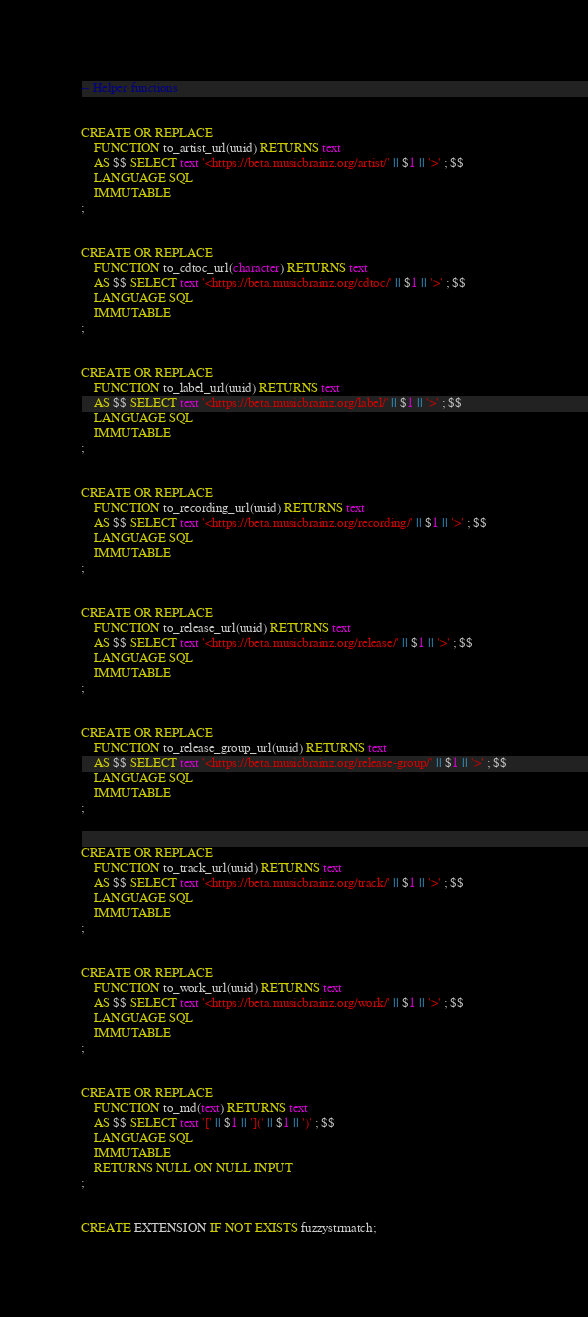Convert code to text. <code><loc_0><loc_0><loc_500><loc_500><_SQL_>-- Helper functions


CREATE OR REPLACE
    FUNCTION to_artist_url(uuid) RETURNS text
    AS $$ SELECT text '<https://beta.musicbrainz.org/artist/' || $1 || '>' ; $$
    LANGUAGE SQL
    IMMUTABLE
;


CREATE OR REPLACE
    FUNCTION to_cdtoc_url(character) RETURNS text
    AS $$ SELECT text '<https://beta.musicbrainz.org/cdtoc/' || $1 || '>' ; $$
    LANGUAGE SQL
    IMMUTABLE
;


CREATE OR REPLACE
    FUNCTION to_label_url(uuid) RETURNS text
    AS $$ SELECT text '<https://beta.musicbrainz.org/label/' || $1 || '>' ; $$
    LANGUAGE SQL
    IMMUTABLE
;


CREATE OR REPLACE
    FUNCTION to_recording_url(uuid) RETURNS text
    AS $$ SELECT text '<https://beta.musicbrainz.org/recording/' || $1 || '>' ; $$
    LANGUAGE SQL
    IMMUTABLE
;


CREATE OR REPLACE
    FUNCTION to_release_url(uuid) RETURNS text
    AS $$ SELECT text '<https://beta.musicbrainz.org/release/' || $1 || '>' ; $$
    LANGUAGE SQL
    IMMUTABLE
;


CREATE OR REPLACE
    FUNCTION to_release_group_url(uuid) RETURNS text
    AS $$ SELECT text '<https://beta.musicbrainz.org/release-group/' || $1 || '>' ; $$
    LANGUAGE SQL
    IMMUTABLE
;


CREATE OR REPLACE
    FUNCTION to_track_url(uuid) RETURNS text
    AS $$ SELECT text '<https://beta.musicbrainz.org/track/' || $1 || '>' ; $$
    LANGUAGE SQL
    IMMUTABLE
;


CREATE OR REPLACE
    FUNCTION to_work_url(uuid) RETURNS text
    AS $$ SELECT text '<https://beta.musicbrainz.org/work/' || $1 || '>' ; $$
    LANGUAGE SQL
    IMMUTABLE
;


CREATE OR REPLACE
    FUNCTION to_md(text) RETURNS text
    AS $$ SELECT text '[' || $1 || '](' || $1 || ')' ; $$
    LANGUAGE SQL
    IMMUTABLE
    RETURNS NULL ON NULL INPUT
;


CREATE EXTENSION IF NOT EXISTS fuzzystrmatch;
</code> 